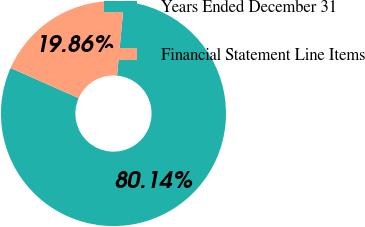Convert chart to OTSL. <chart><loc_0><loc_0><loc_500><loc_500><pie_chart><fcel>Years Ended December 31<fcel>Financial Statement Line Items<nl><fcel>80.14%<fcel>19.86%<nl></chart> 